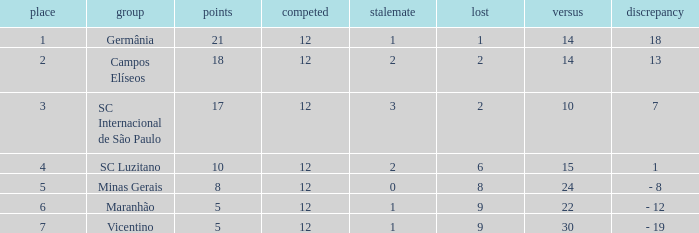What difference has a points greater than 10, and a drawn less than 2? 18.0. 